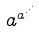<formula> <loc_0><loc_0><loc_500><loc_500>a ^ { a ^ { \cdot ^ { \cdot ^ { \cdot } } } }</formula> 